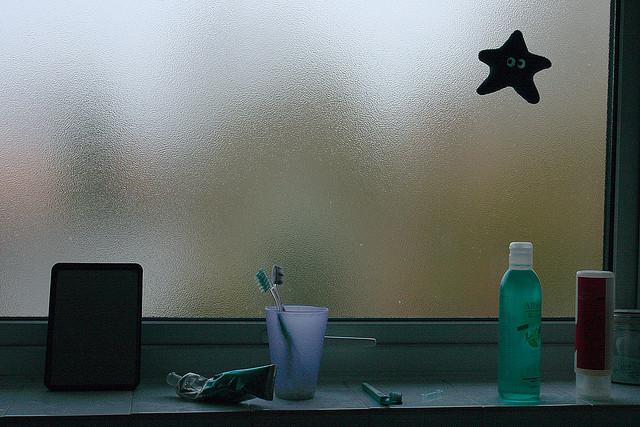What do you put on your lips?
Concise answer only. Toothbrush. What are the toothbrushes laying on?
Quick response, please. Counter. Is the glass plastic?
Give a very brief answer. Yes. How many toothbrushes are there?
Short answer required. 2. What color are the bristles?
Be succinct. Blue white. What color bristles are in this toothbrush?
Give a very brief answer. Green. What do you do with the black object?
Concise answer only. Nothing. What is to the right of the toothbrush on this shelf?
Short answer required. Shampoo. Was this picture taken outdoors?
Give a very brief answer. No. What marine animal is shaped like the window decoration?
Quick response, please. Starfish. What brand are these toothbrushes?
Be succinct. Colgate. What is the object to the right of the cups?
Short answer required. Toothbrush. What color cup are the toothbrushes in?
Be succinct. Purple. What is the black shape on the window?
Short answer required. Star. Is there a doorway?
Give a very brief answer. No. What kind of toothbrush is this?
Short answer required. Manual. Which toothbrush is more worn out?
Keep it brief. Left. 